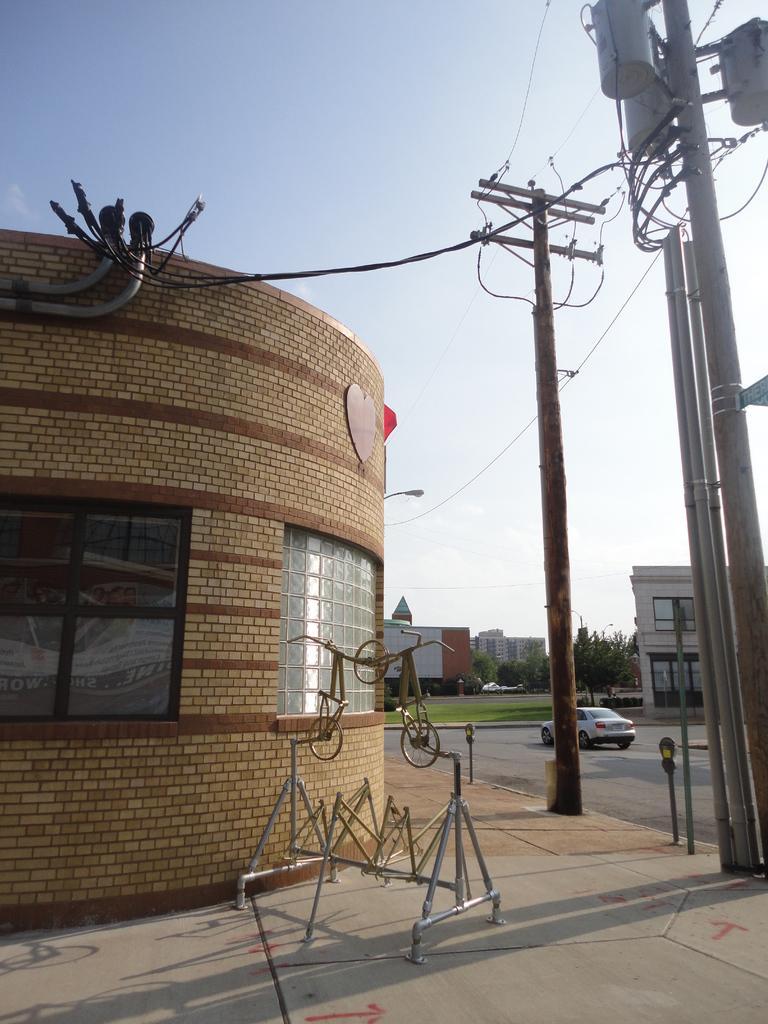Could you give a brief overview of what you see in this image? On the right side of the image we can see current polls, sign board, building and car. On the left side of the image there is a building and wires. In the background there are buildings, trees and sky. 